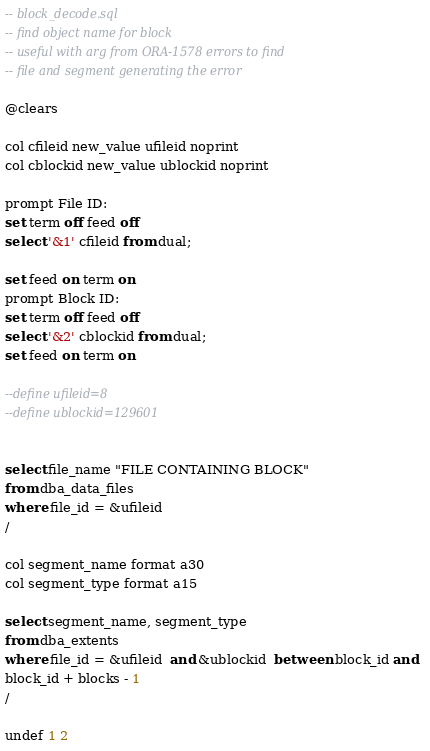<code> <loc_0><loc_0><loc_500><loc_500><_SQL_>

-- block_decode.sql
-- find object name for block
-- useful with arg from ORA-1578 errors to find
-- file and segment generating the error

@clears

col cfileid new_value ufileid noprint
col cblockid new_value ublockid noprint

prompt File ID: 
set term off feed off
select '&1' cfileid from dual;

set feed on term on
prompt Block ID:
set term off feed off
select '&2' cblockid from dual;
set feed on term on

--define ufileid=8
--define ublockid=129601


select file_name "FILE CONTAINING BLOCK"
from dba_data_files
where file_id = &ufileid
/

col segment_name format a30
col segment_type format a15

select segment_name, segment_type 
from dba_extents  
where file_id = &ufileid  and &ublockid  between block_id and  
block_id + blocks - 1
/

undef 1 2

</code> 